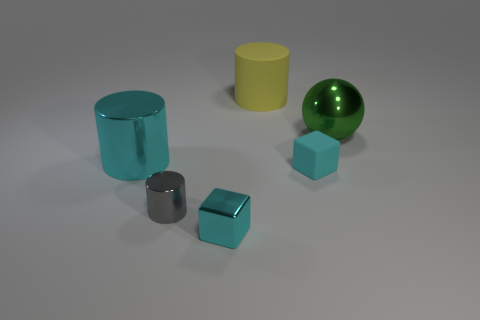Subtract all yellow spheres. Subtract all cyan blocks. How many spheres are left? 1 Add 4 gray metallic things. How many objects exist? 10 Subtract all blocks. How many objects are left? 4 Add 2 yellow metal cylinders. How many yellow metal cylinders exist? 2 Subtract 0 purple cubes. How many objects are left? 6 Subtract all cylinders. Subtract all gray objects. How many objects are left? 2 Add 1 big green metallic objects. How many big green metallic objects are left? 2 